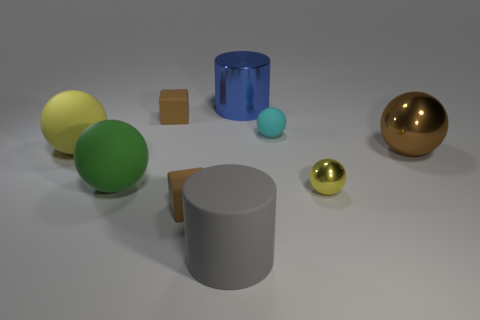How many yellow balls must be subtracted to get 1 yellow balls? 1 Subtract all big spheres. How many spheres are left? 2 Subtract all brown balls. How many balls are left? 4 Add 1 small brown balls. How many objects exist? 10 Subtract all cubes. How many objects are left? 7 Subtract 1 spheres. How many spheres are left? 4 Subtract all tiny gray shiny cylinders. Subtract all green spheres. How many objects are left? 8 Add 1 tiny rubber blocks. How many tiny rubber blocks are left? 3 Add 2 large red metal blocks. How many large red metal blocks exist? 2 Subtract 1 blue cylinders. How many objects are left? 8 